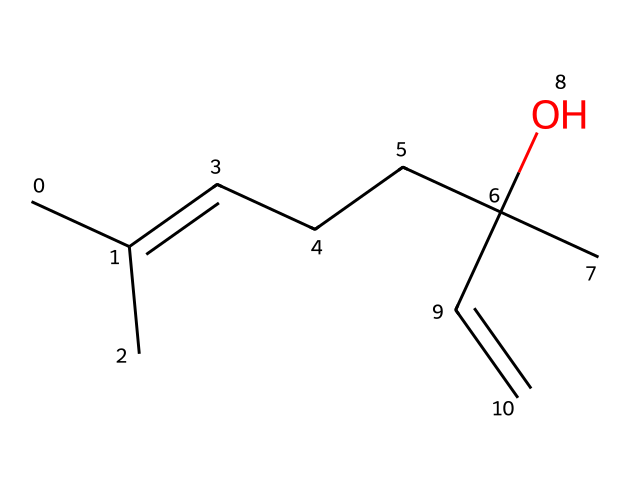What is the name of the aromatic compound represented by this structure? The chemical structure corresponds to a compound known for its fragrance in lavender. This structure features a cyclohexene ring which is characteristic of many aromatic compounds, but the presence of specific substituents allows us to identify it as linalool.
Answer: linalool How many carbon atoms are present in this compound? By examining the structure, we count a total of 10 carbon atoms. These atoms are part of both the hydrocarbon chain and the cyclic structure, which contribute to the overall molecular formula.
Answer: 10 Does this compound contain any functional groups? In looking closely at the structure, we can identify a hydroxyl group (-OH) attached to one of the carbon atoms in the side chain, which indicates the presence of alcohol. This functional group is vital for the characteristics of the compound.
Answer: yes What type of chemical is linalool? Linalool, based on its structure, is classified as a terpenoid. This classification is based on its origin from plant compounds (terpenes) and the presence of a ring structure, common in this type of chemical.
Answer: terpenoid Can this compound participate in hydrogen bonding? The presence of the hydroxyl group (-OH) suggests that linalool can form hydrogen bonds due to the electronegative oxygen atom attached to a hydrogen atom, which allows interactions with other molecules.
Answer: yes Is linalool naturally occurring? Linalool is a natural product, primarily found in the essential oils of lavender and other plants, demonstrating that it is a common component of many plant-based fragrances and is used widely in perfumery.
Answer: yes 